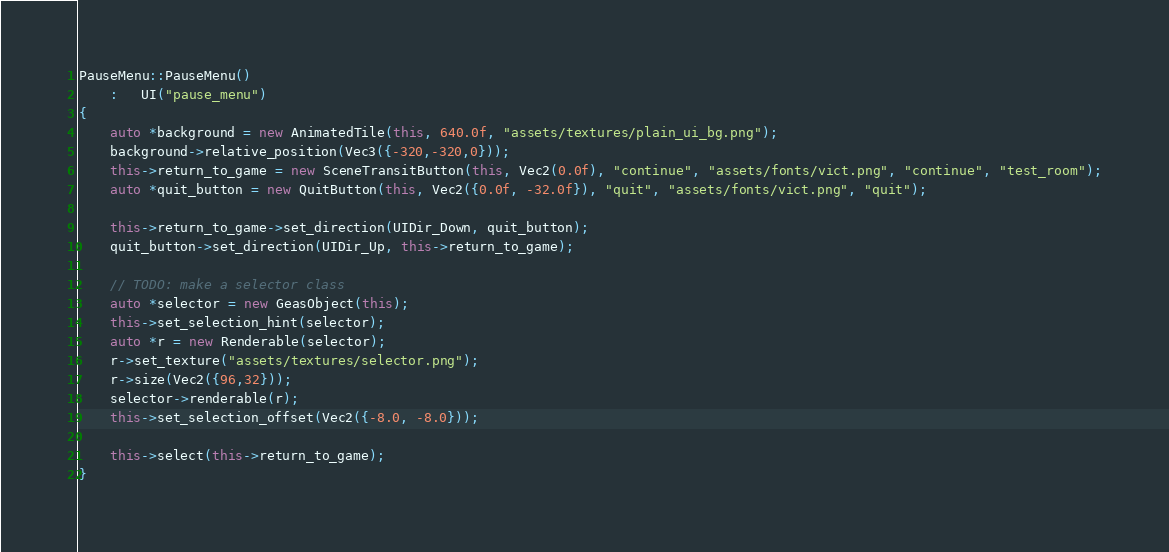<code> <loc_0><loc_0><loc_500><loc_500><_C++_>
PauseMenu::PauseMenu()
    :   UI("pause_menu")
{
    auto *background = new AnimatedTile(this, 640.0f, "assets/textures/plain_ui_bg.png");
    background->relative_position(Vec3({-320,-320,0}));
    this->return_to_game = new SceneTransitButton(this, Vec2(0.0f), "continue", "assets/fonts/vict.png", "continue", "test_room");
    auto *quit_button = new QuitButton(this, Vec2({0.0f, -32.0f}), "quit", "assets/fonts/vict.png", "quit");

    this->return_to_game->set_direction(UIDir_Down, quit_button);
    quit_button->set_direction(UIDir_Up, this->return_to_game);

    // TODO: make a selector class
    auto *selector = new GeasObject(this);
    this->set_selection_hint(selector);
    auto *r = new Renderable(selector);
    r->set_texture("assets/textures/selector.png");
    r->size(Vec2({96,32}));
    selector->renderable(r);
    this->set_selection_offset(Vec2({-8.0, -8.0}));

    this->select(this->return_to_game);
}</code> 